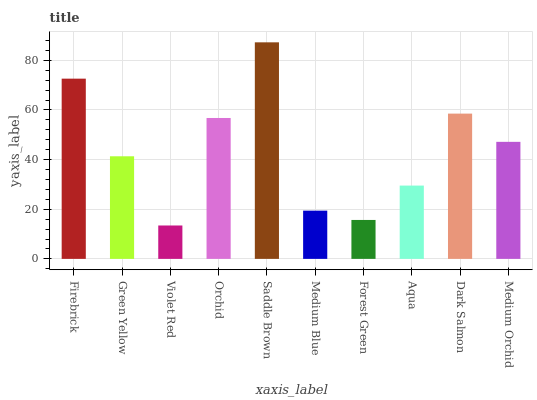Is Violet Red the minimum?
Answer yes or no. Yes. Is Saddle Brown the maximum?
Answer yes or no. Yes. Is Green Yellow the minimum?
Answer yes or no. No. Is Green Yellow the maximum?
Answer yes or no. No. Is Firebrick greater than Green Yellow?
Answer yes or no. Yes. Is Green Yellow less than Firebrick?
Answer yes or no. Yes. Is Green Yellow greater than Firebrick?
Answer yes or no. No. Is Firebrick less than Green Yellow?
Answer yes or no. No. Is Medium Orchid the high median?
Answer yes or no. Yes. Is Green Yellow the low median?
Answer yes or no. Yes. Is Aqua the high median?
Answer yes or no. No. Is Medium Blue the low median?
Answer yes or no. No. 